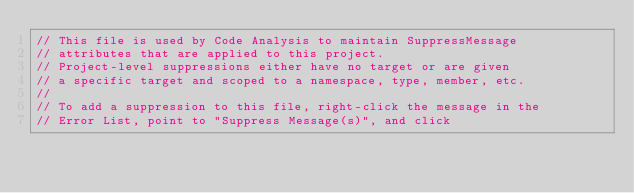<code> <loc_0><loc_0><loc_500><loc_500><_C#_>// This file is used by Code Analysis to maintain SuppressMessage
// attributes that are applied to this project.
// Project-level suppressions either have no target or are given
// a specific target and scoped to a namespace, type, member, etc.
//
// To add a suppression to this file, right-click the message in the
// Error List, point to "Suppress Message(s)", and click</code> 